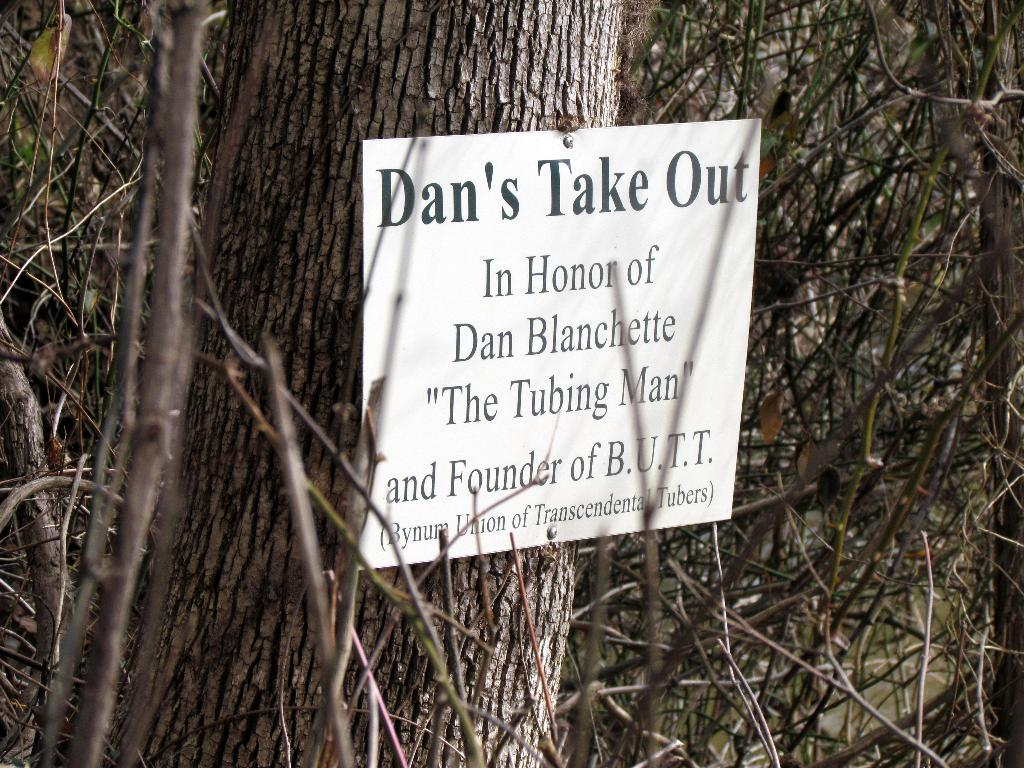What type of plant can be seen in the image? There is a tree in the image. What is attached to the tree? There is a board nailed to the tree. What is written on the board? There is text written on the board. How many bananas are hanging from the tree in the image? There are no bananas present in the image; it features a tree with a board nailed to it. What type of agreement is being discussed on the board in the image? There is no mention of an agreement in the image; it only features a tree with a board nailed to it and text written on the board. 